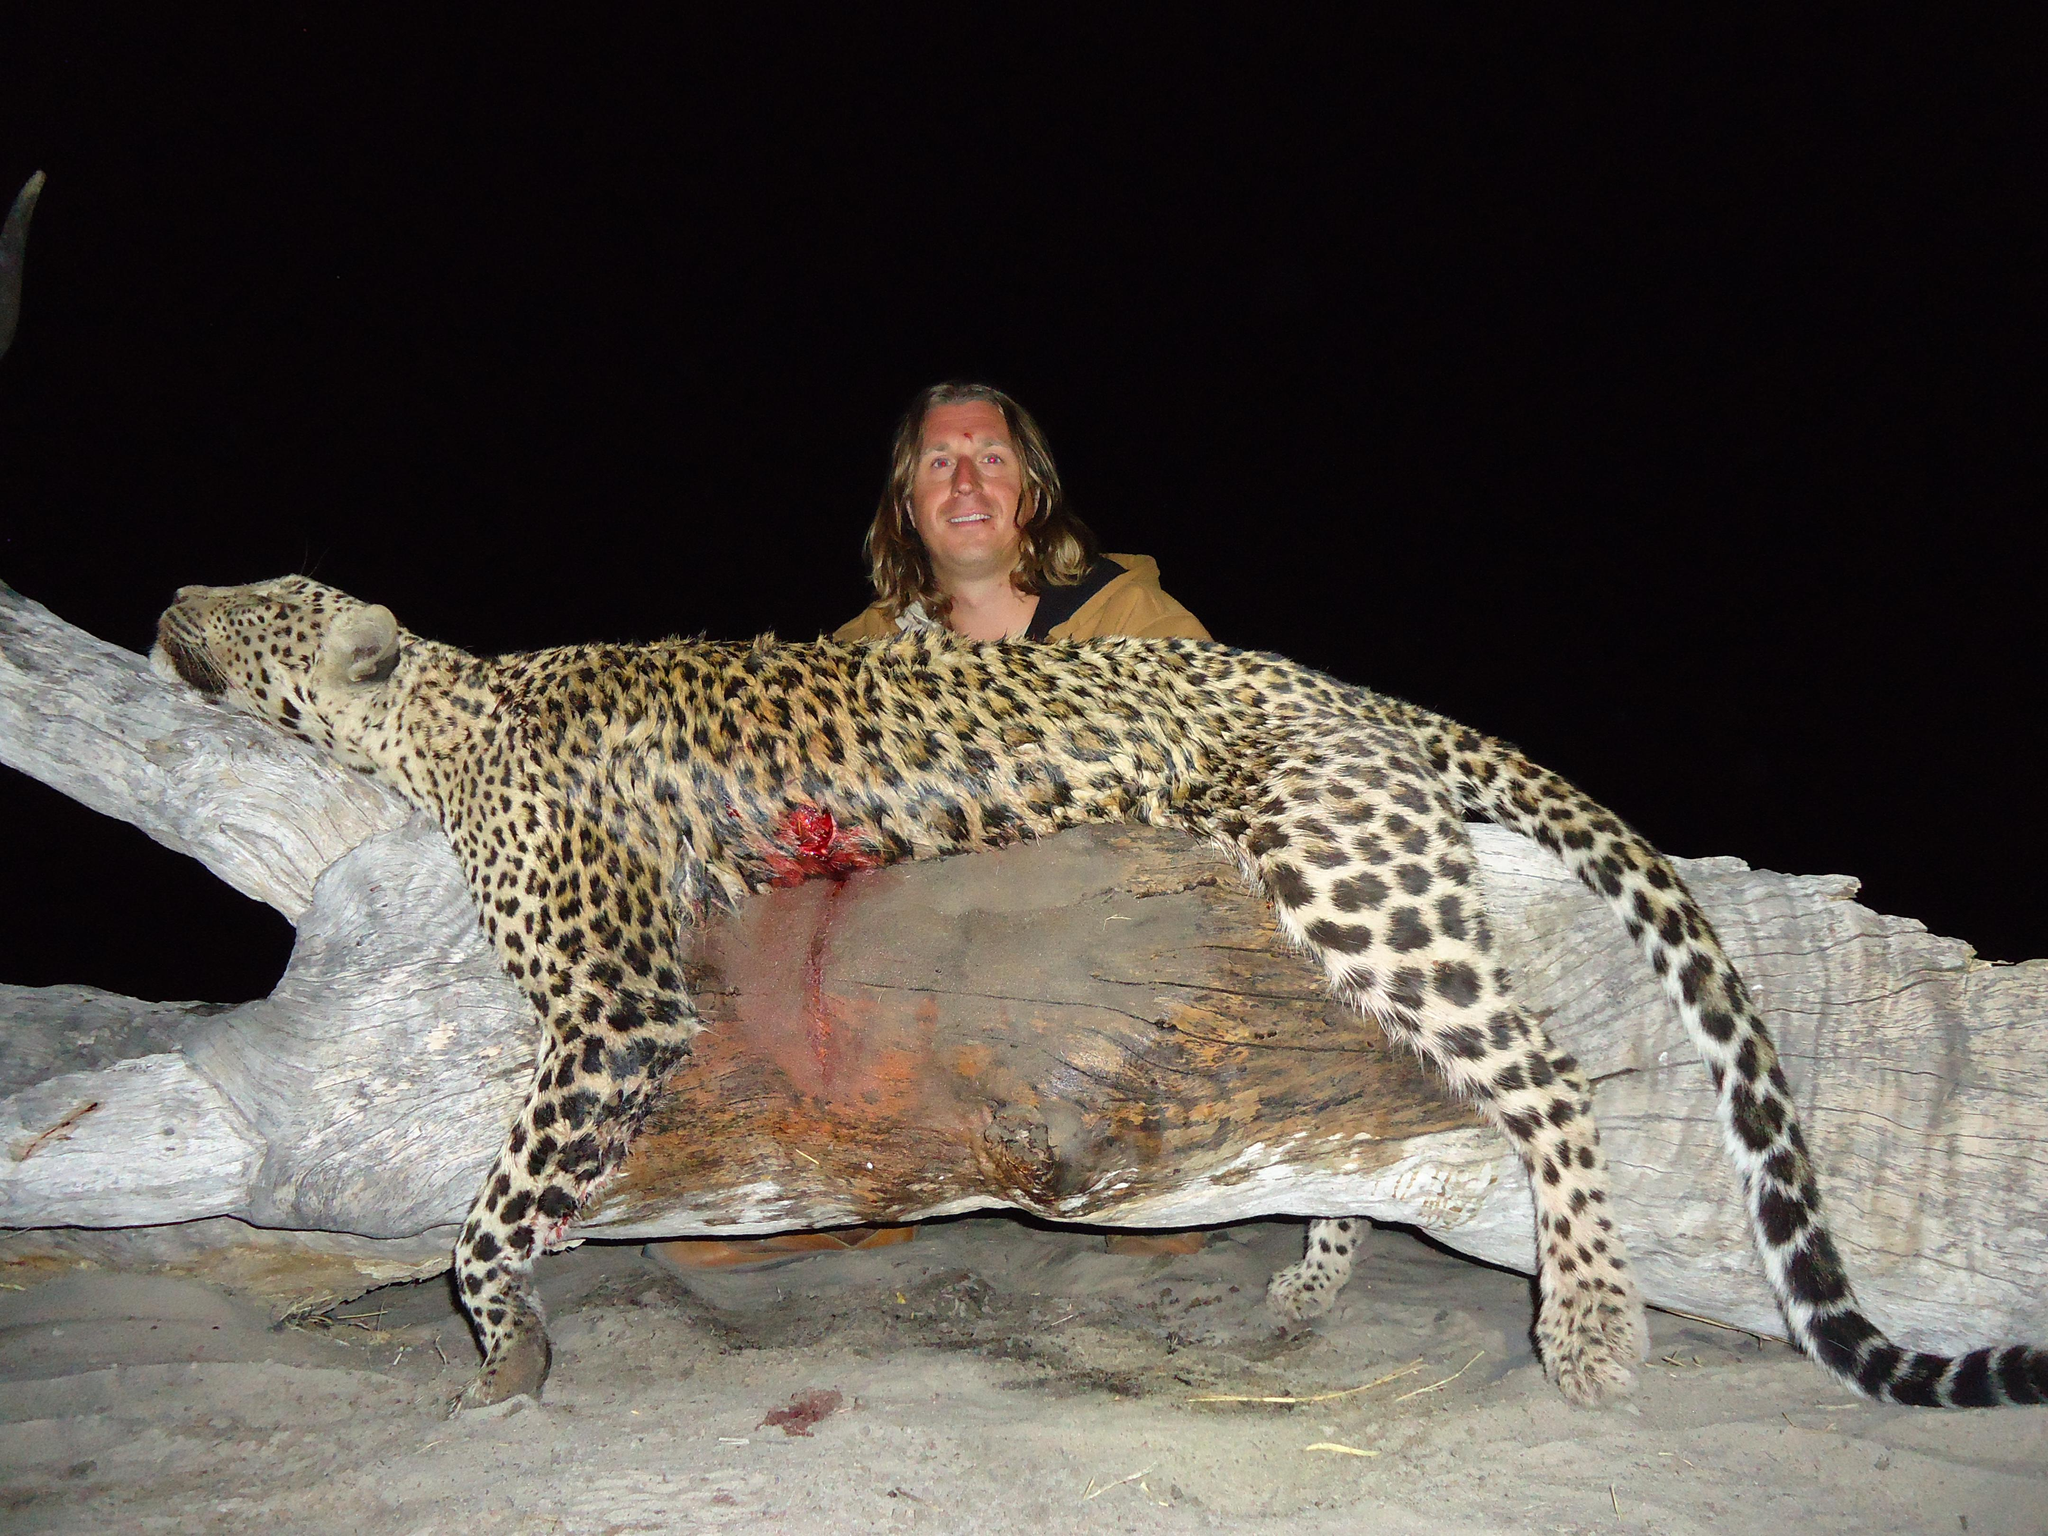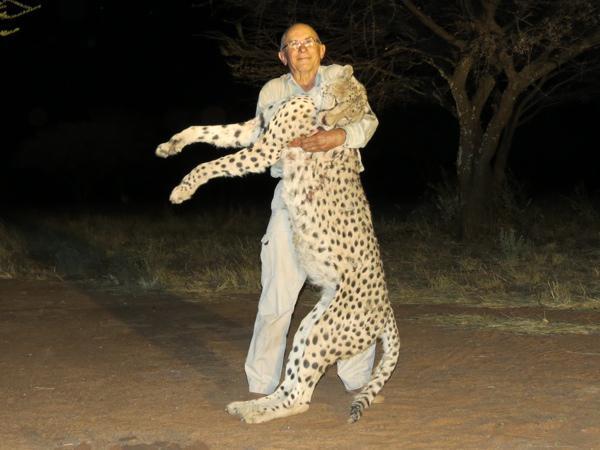The first image is the image on the left, the second image is the image on the right. Analyze the images presented: Is the assertion "A man is holding the cat in one of the images upright." valid? Answer yes or no. Yes. 